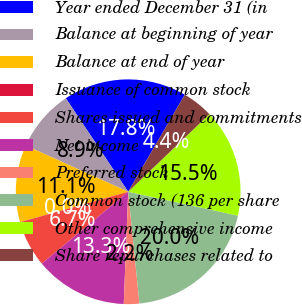Convert chart to OTSL. <chart><loc_0><loc_0><loc_500><loc_500><pie_chart><fcel>Year ended December 31 (in<fcel>Balance at beginning of year<fcel>Balance at end of year<fcel>Issuance of common stock<fcel>Shares issued and commitments<fcel>Net income<fcel>Preferred stock<fcel>Common stock (136 per share<fcel>Other comprehensive income<fcel>Share repurchases related to<nl><fcel>17.77%<fcel>8.89%<fcel>11.11%<fcel>0.01%<fcel>6.67%<fcel>13.33%<fcel>2.23%<fcel>19.99%<fcel>15.55%<fcel>4.45%<nl></chart> 